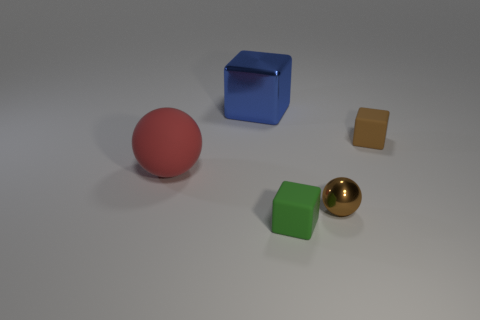Add 2 big red balls. How many objects exist? 7 Subtract all matte cubes. How many cubes are left? 1 Subtract 0 yellow cubes. How many objects are left? 5 Subtract all blocks. How many objects are left? 2 Subtract 3 cubes. How many cubes are left? 0 Subtract all yellow blocks. Subtract all purple cylinders. How many blocks are left? 3 Subtract all cyan cylinders. How many blue blocks are left? 1 Subtract all red shiny balls. Subtract all brown shiny objects. How many objects are left? 4 Add 2 brown shiny spheres. How many brown shiny spheres are left? 3 Add 1 small cyan shiny cylinders. How many small cyan shiny cylinders exist? 1 